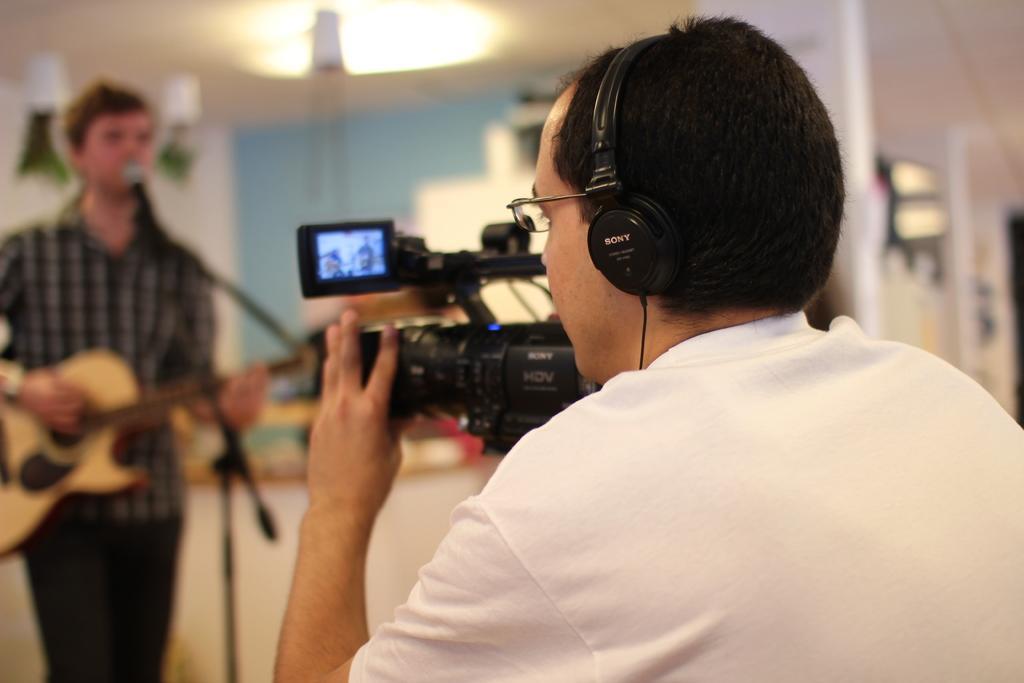Describe this image in one or two sentences. In the picture we can see a man holding a camera and capturing a man opposite to him, a man is holding a guitar near the microphone, in the background we can see a light, a wall which is blue in color. 